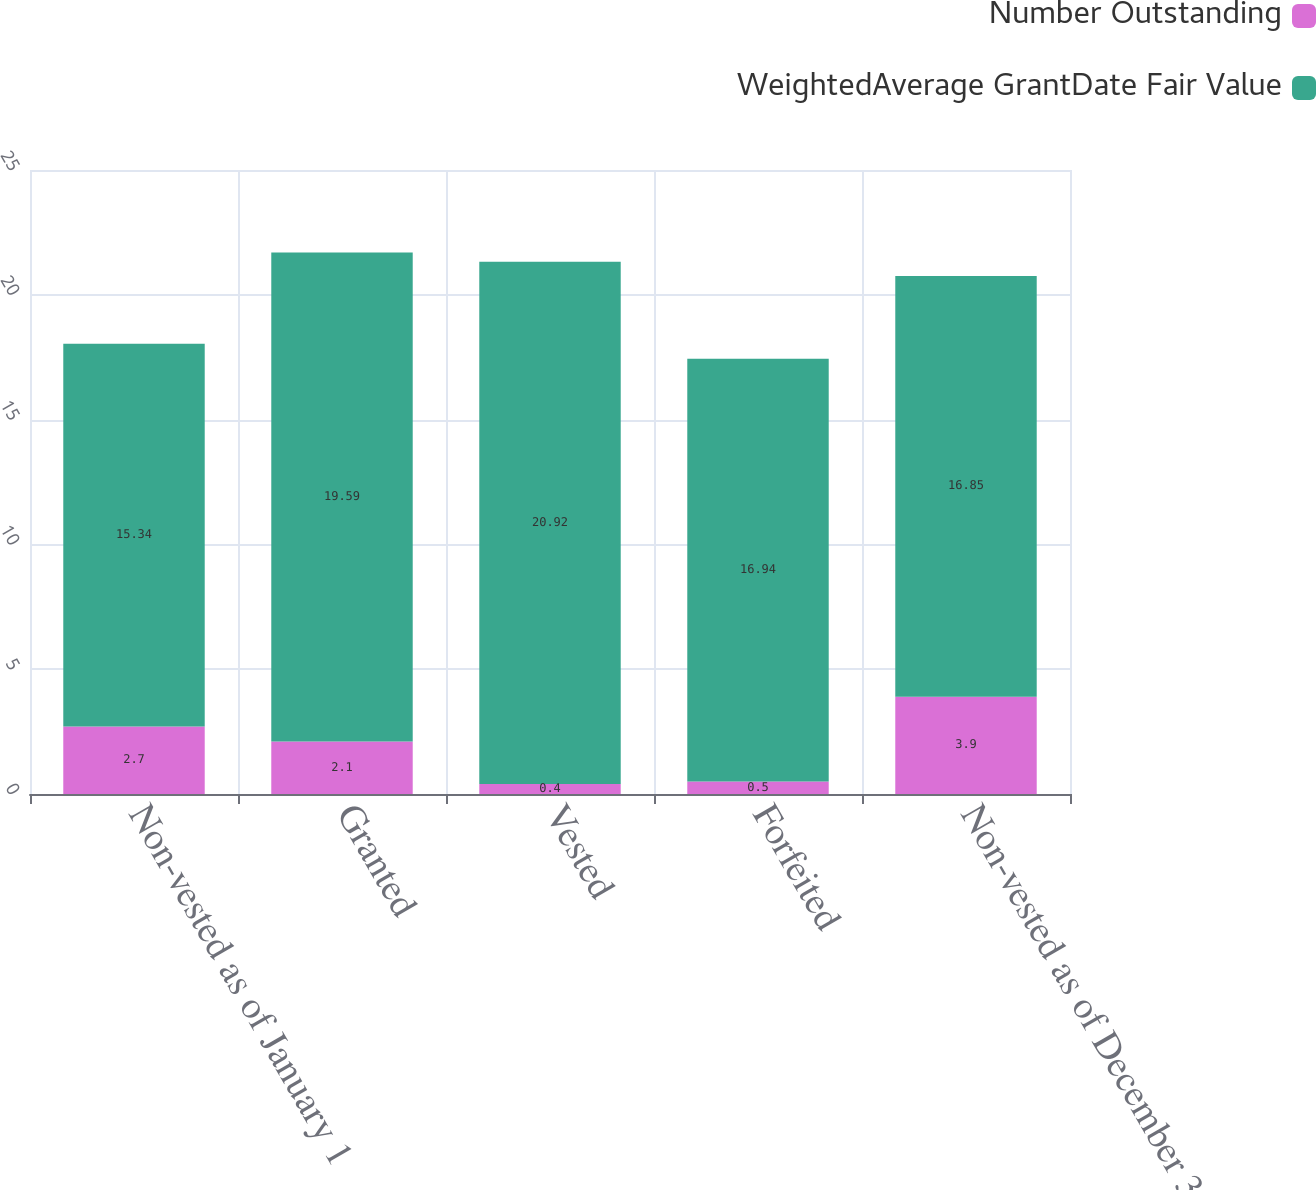<chart> <loc_0><loc_0><loc_500><loc_500><stacked_bar_chart><ecel><fcel>Non-vested as of January 1<fcel>Granted<fcel>Vested<fcel>Forfeited<fcel>Non-vested as of December 31<nl><fcel>Number Outstanding<fcel>2.7<fcel>2.1<fcel>0.4<fcel>0.5<fcel>3.9<nl><fcel>WeightedAverage GrantDate Fair Value<fcel>15.34<fcel>19.59<fcel>20.92<fcel>16.94<fcel>16.85<nl></chart> 